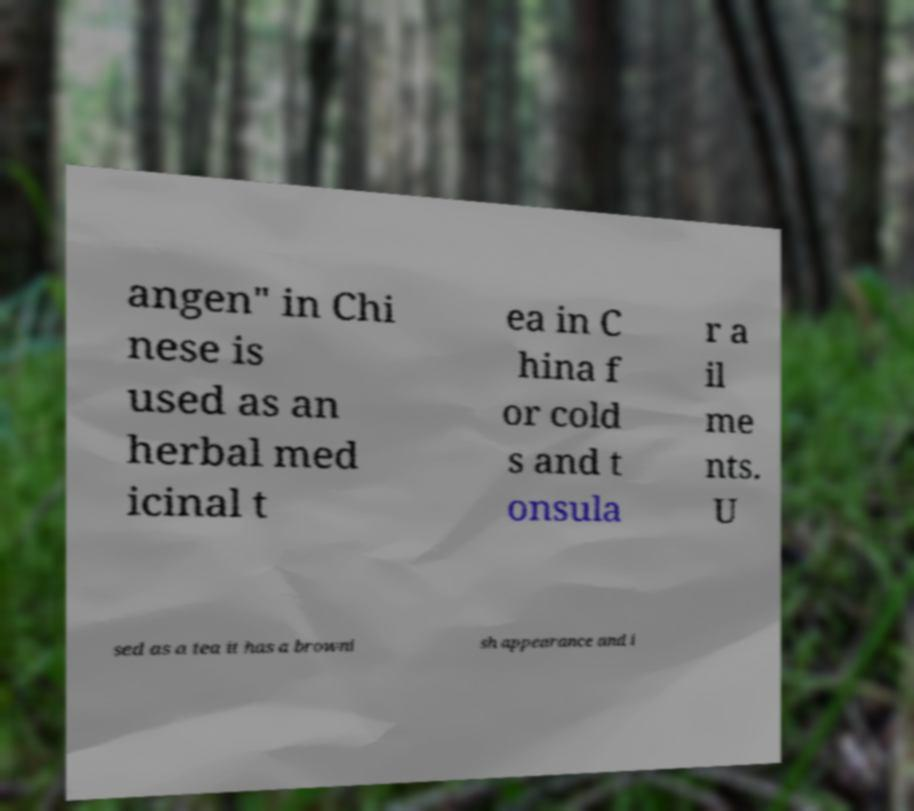Can you read and provide the text displayed in the image?This photo seems to have some interesting text. Can you extract and type it out for me? angen" in Chi nese is used as an herbal med icinal t ea in C hina f or cold s and t onsula r a il me nts. U sed as a tea it has a browni sh appearance and i 